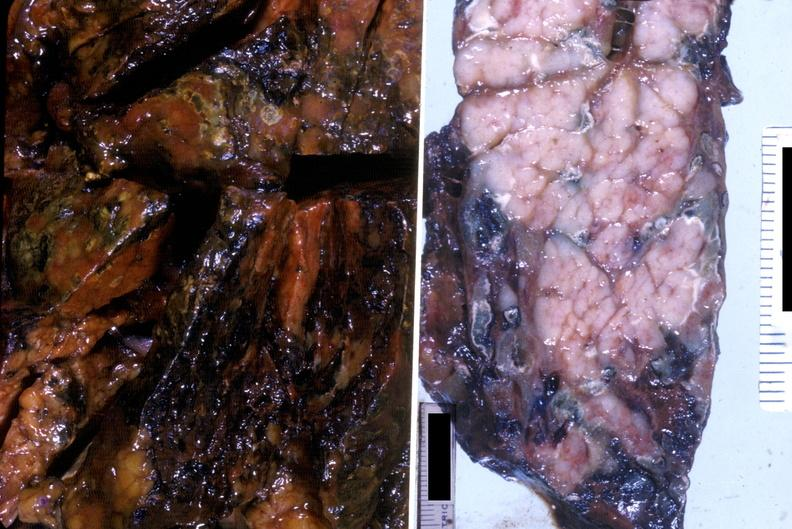what does this image show?
Answer the question using a single word or phrase. Acute hemorrhagic pancreatitis 